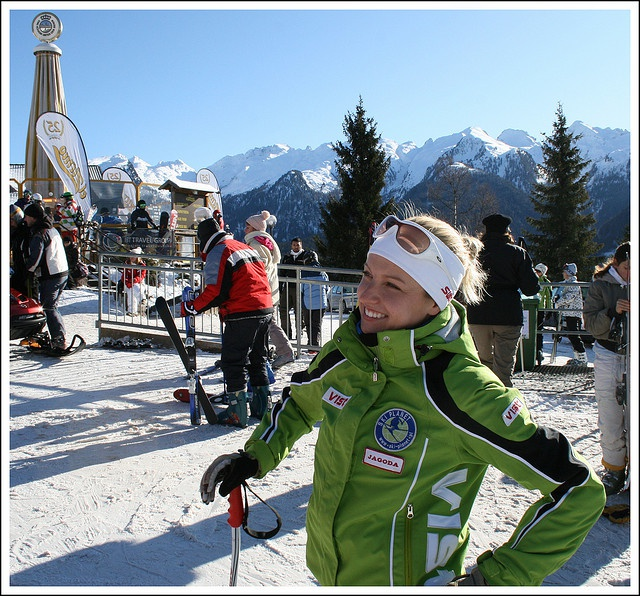Describe the objects in this image and their specific colors. I can see people in black, darkgreen, and ivory tones, people in black, maroon, gray, and darkblue tones, people in black, gray, and white tones, people in black and gray tones, and people in black, white, darkgray, and gray tones in this image. 